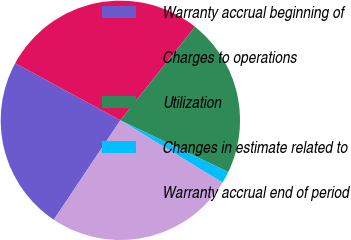<chart> <loc_0><loc_0><loc_500><loc_500><pie_chart><fcel>Warranty accrual beginning of<fcel>Charges to operations<fcel>Utilization<fcel>Changes in estimate related to<fcel>Warranty accrual end of period<nl><fcel>23.53%<fcel>27.81%<fcel>21.39%<fcel>1.6%<fcel>25.67%<nl></chart> 